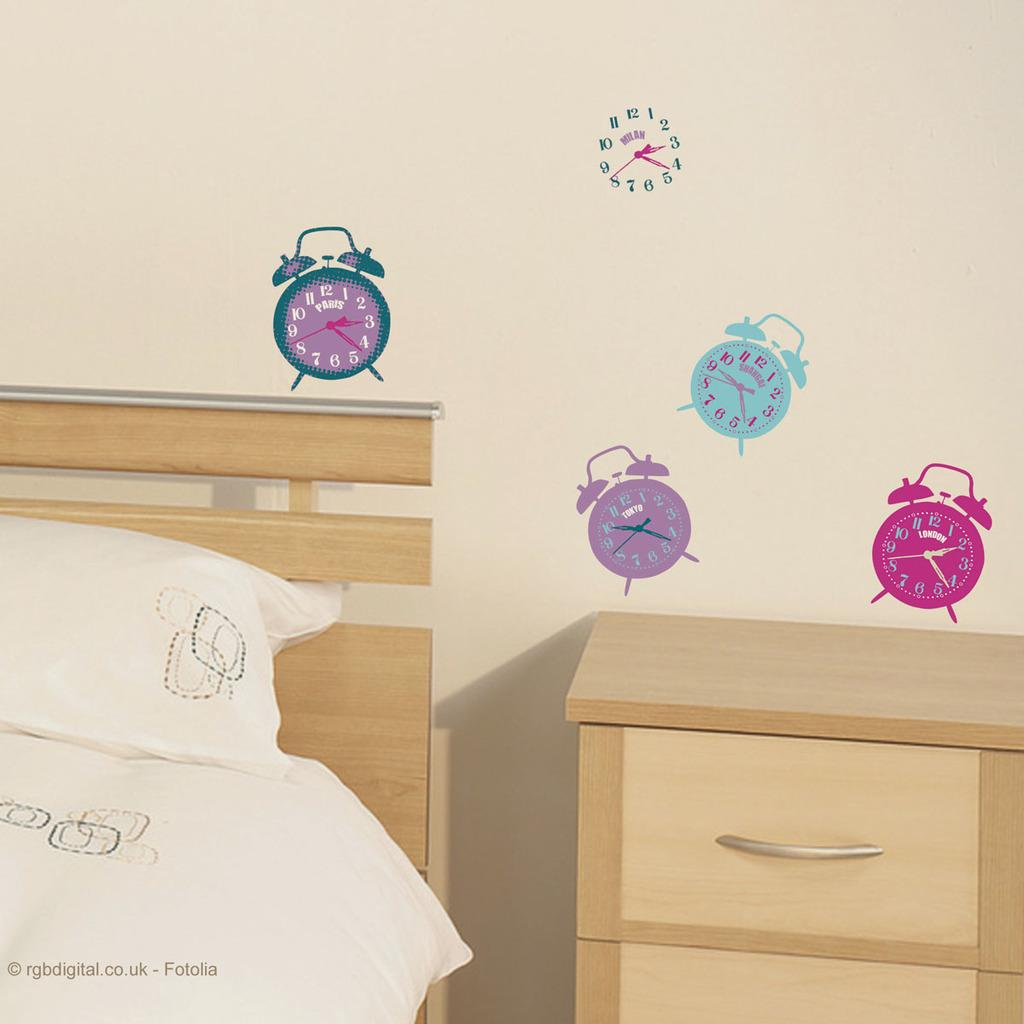<image>
Render a clear and concise summary of the photo. A copyrighted image of a childrens room by Fotolia 